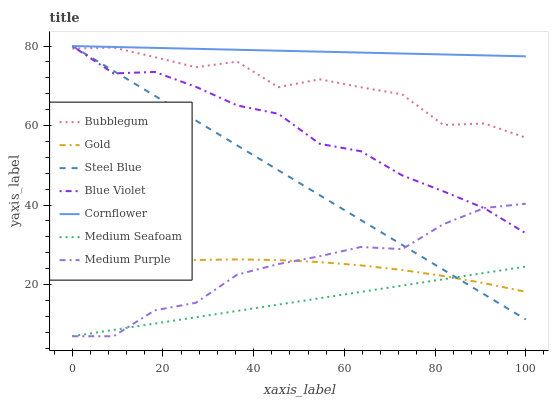Does Medium Seafoam have the minimum area under the curve?
Answer yes or no. Yes. Does Cornflower have the maximum area under the curve?
Answer yes or no. Yes. Does Gold have the minimum area under the curve?
Answer yes or no. No. Does Gold have the maximum area under the curve?
Answer yes or no. No. Is Medium Seafoam the smoothest?
Answer yes or no. Yes. Is Bubblegum the roughest?
Answer yes or no. Yes. Is Gold the smoothest?
Answer yes or no. No. Is Gold the roughest?
Answer yes or no. No. Does Medium Purple have the lowest value?
Answer yes or no. Yes. Does Gold have the lowest value?
Answer yes or no. No. Does Steel Blue have the highest value?
Answer yes or no. Yes. Does Gold have the highest value?
Answer yes or no. No. Is Medium Seafoam less than Cornflower?
Answer yes or no. Yes. Is Blue Violet greater than Gold?
Answer yes or no. Yes. Does Steel Blue intersect Blue Violet?
Answer yes or no. Yes. Is Steel Blue less than Blue Violet?
Answer yes or no. No. Is Steel Blue greater than Blue Violet?
Answer yes or no. No. Does Medium Seafoam intersect Cornflower?
Answer yes or no. No. 